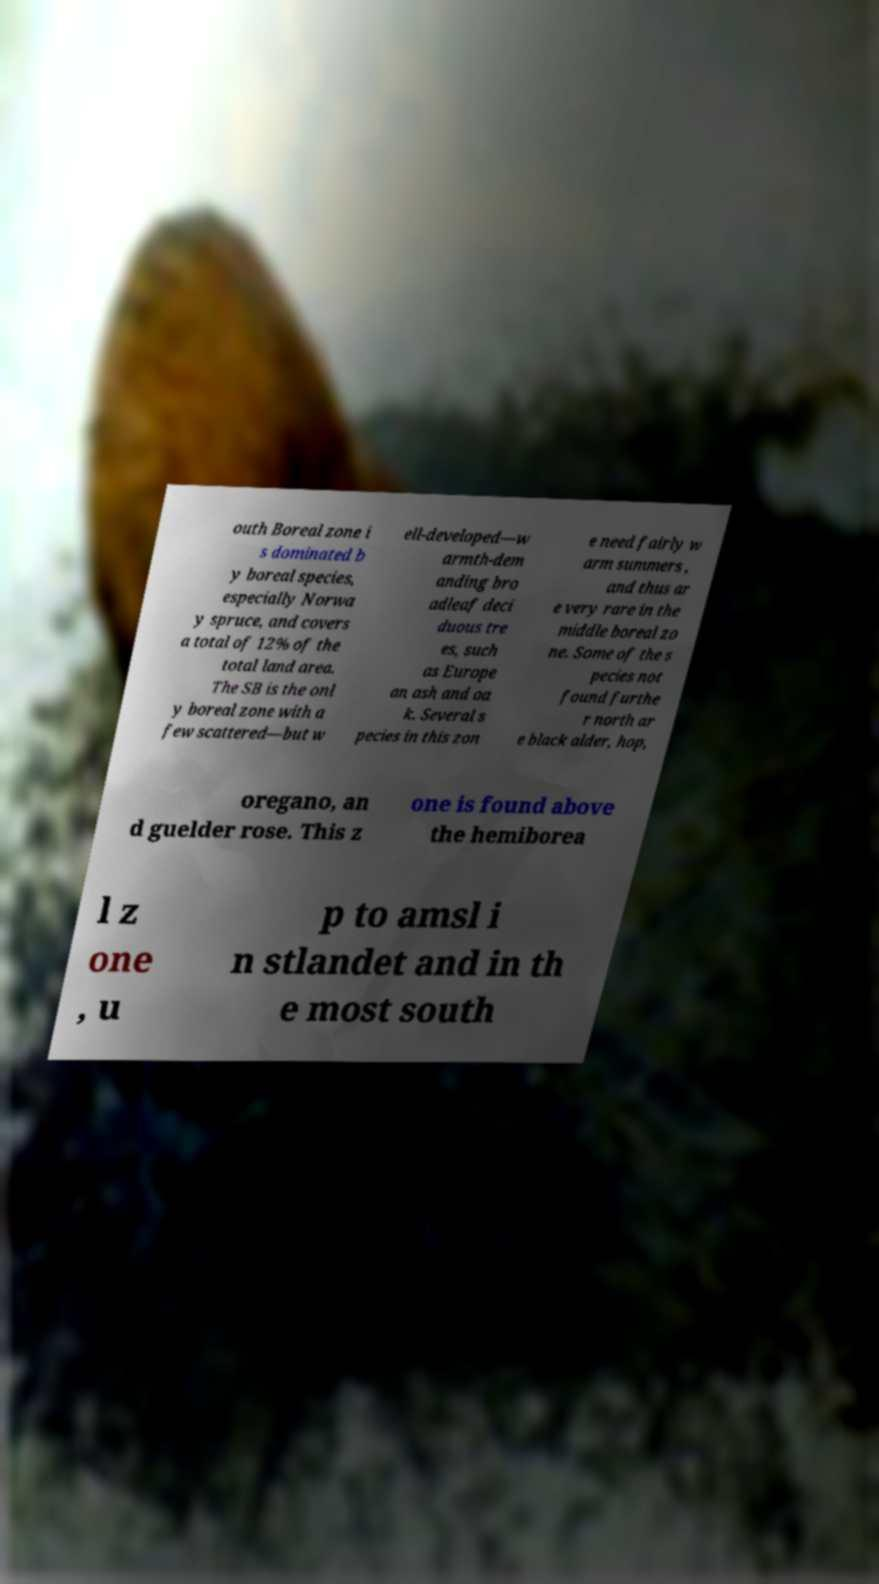Can you accurately transcribe the text from the provided image for me? outh Boreal zone i s dominated b y boreal species, especially Norwa y spruce, and covers a total of 12% of the total land area. The SB is the onl y boreal zone with a few scattered—but w ell-developed—w armth-dem anding bro adleaf deci duous tre es, such as Europe an ash and oa k. Several s pecies in this zon e need fairly w arm summers , and thus ar e very rare in the middle boreal zo ne. Some of the s pecies not found furthe r north ar e black alder, hop, oregano, an d guelder rose. This z one is found above the hemiborea l z one , u p to amsl i n stlandet and in th e most south 